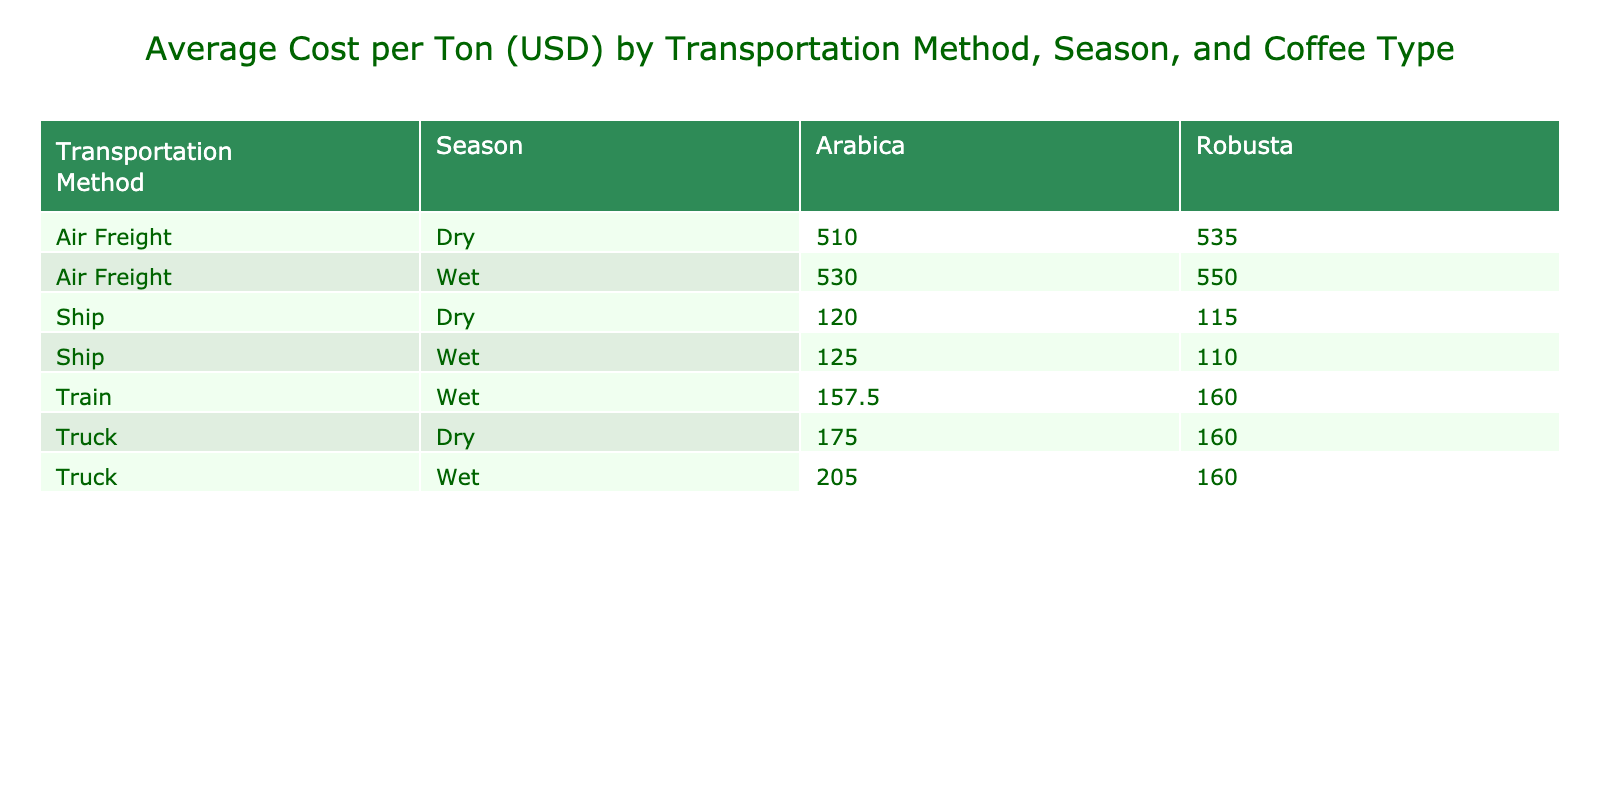What is the transportation cost per ton for air freight during the dry season for Arabica coffee? Referring to the table, for air freight during the dry season, the cost per ton listed under Arabica coffee is 500 USD.
Answer: 500 USD What is the average cost per ton for shipping both coffee types during wet season using the train? To find the average, we look at the costs for the wet season, which are 170 USD for Arabica and 140 USD for Robusta. The average is calculated as (170 + 140) / 2 = 155 USD.
Answer: 155 USD Is the cost per ton for transporting Robusta coffee by truck higher than 200 USD? Checking the table, the costs listed for Robusta coffee using the truck are 200 USD and 205 USD. Since both values meet or exceed 200 USD, the answer is yes.
Answer: Yes What is the difference in transportation cost per ton between air freight for Arabica and ship for Robusta during the dry season? For Arabica using air freight, the cost is 500 USD, while for Robusta shipped during the dry season, it is 115 USD. The difference is calculated as 500 - 115 = 385 USD.
Answer: 385 USD What is the most expensive transportation method for Arabica coffee? Reviewing the table, air freight for Arabica coffee costs 500 USD, which is higher than the costs for truck (150 USD), train (145 USD), and ship (120 USD). Hence, air freight is the most expensive.
Answer: Air Freight 